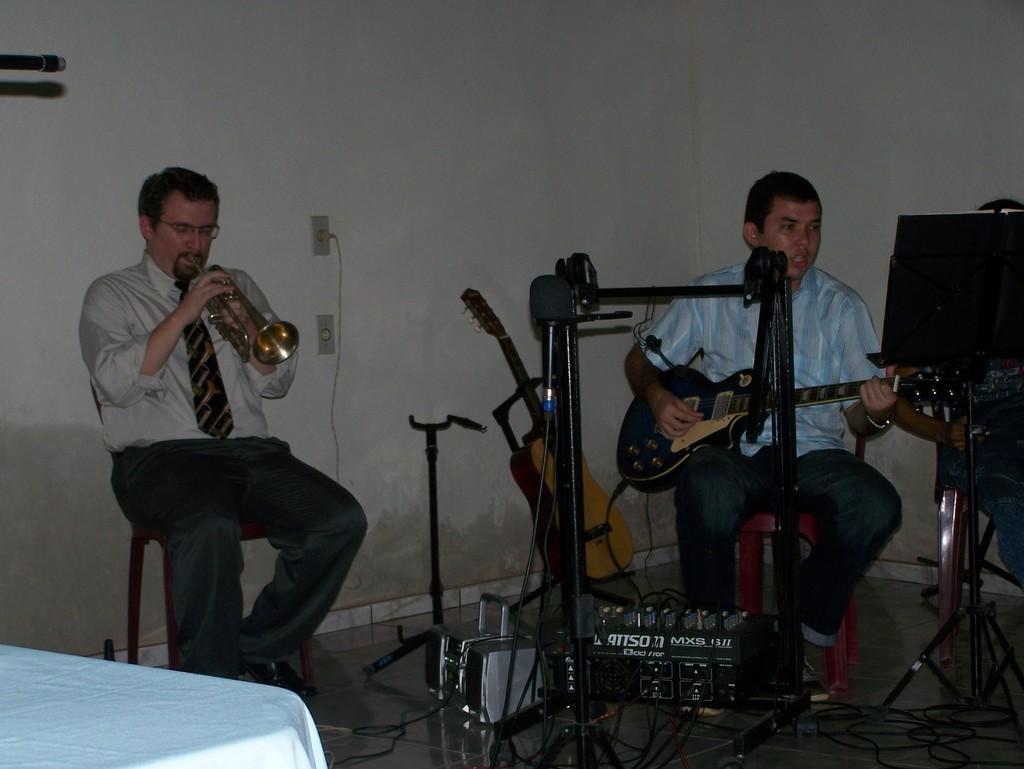How would you summarize this image in a sentence or two? In this image i can see 2 persons sitting and holding musical instruments in their hands. In the background i can see a wall and a switch board. 